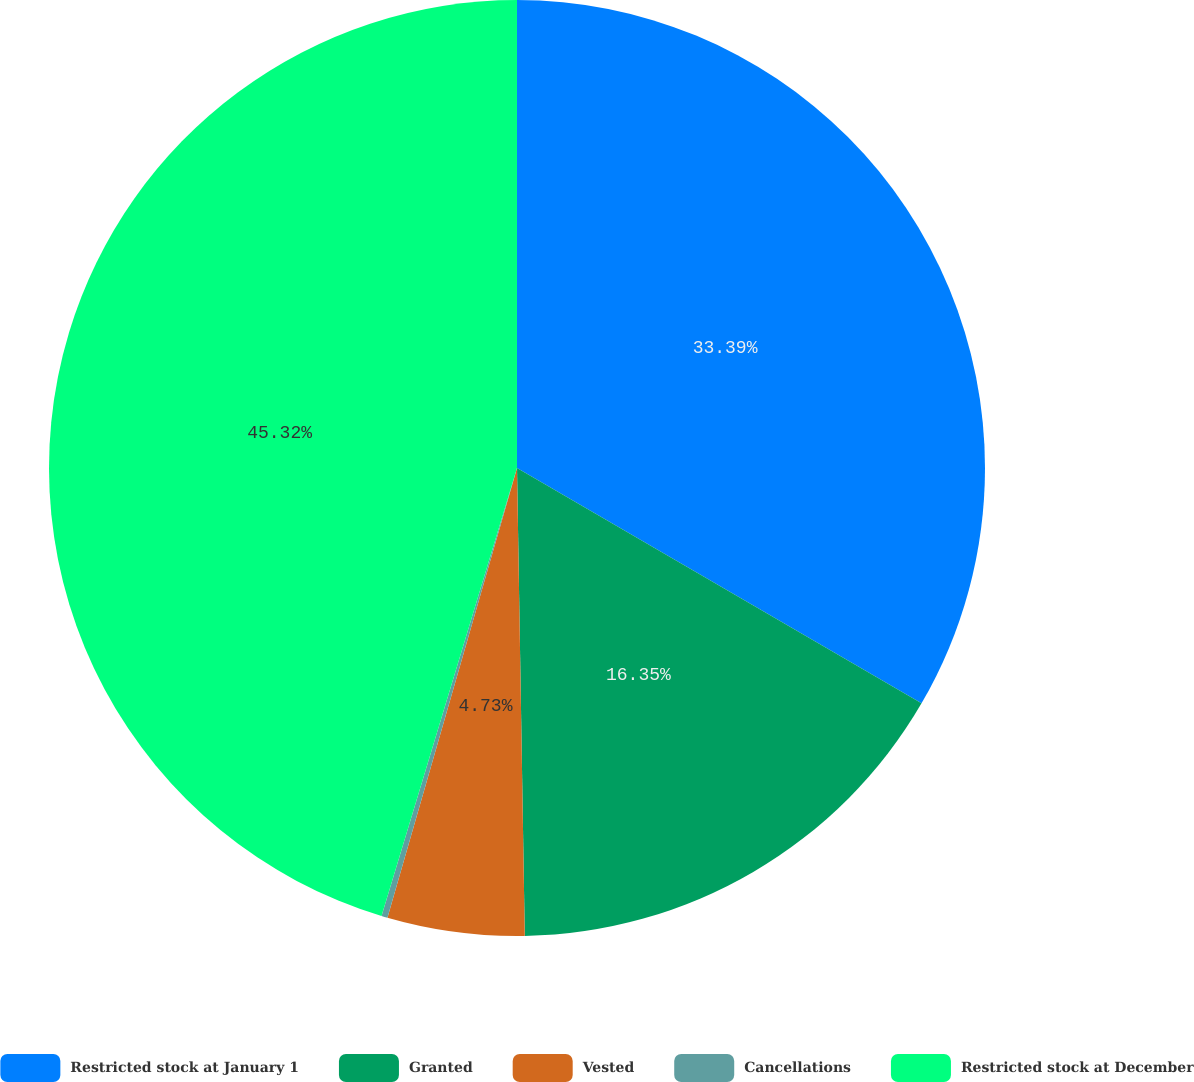<chart> <loc_0><loc_0><loc_500><loc_500><pie_chart><fcel>Restricted stock at January 1<fcel>Granted<fcel>Vested<fcel>Cancellations<fcel>Restricted stock at December<nl><fcel>33.39%<fcel>16.35%<fcel>4.73%<fcel>0.21%<fcel>45.33%<nl></chart> 